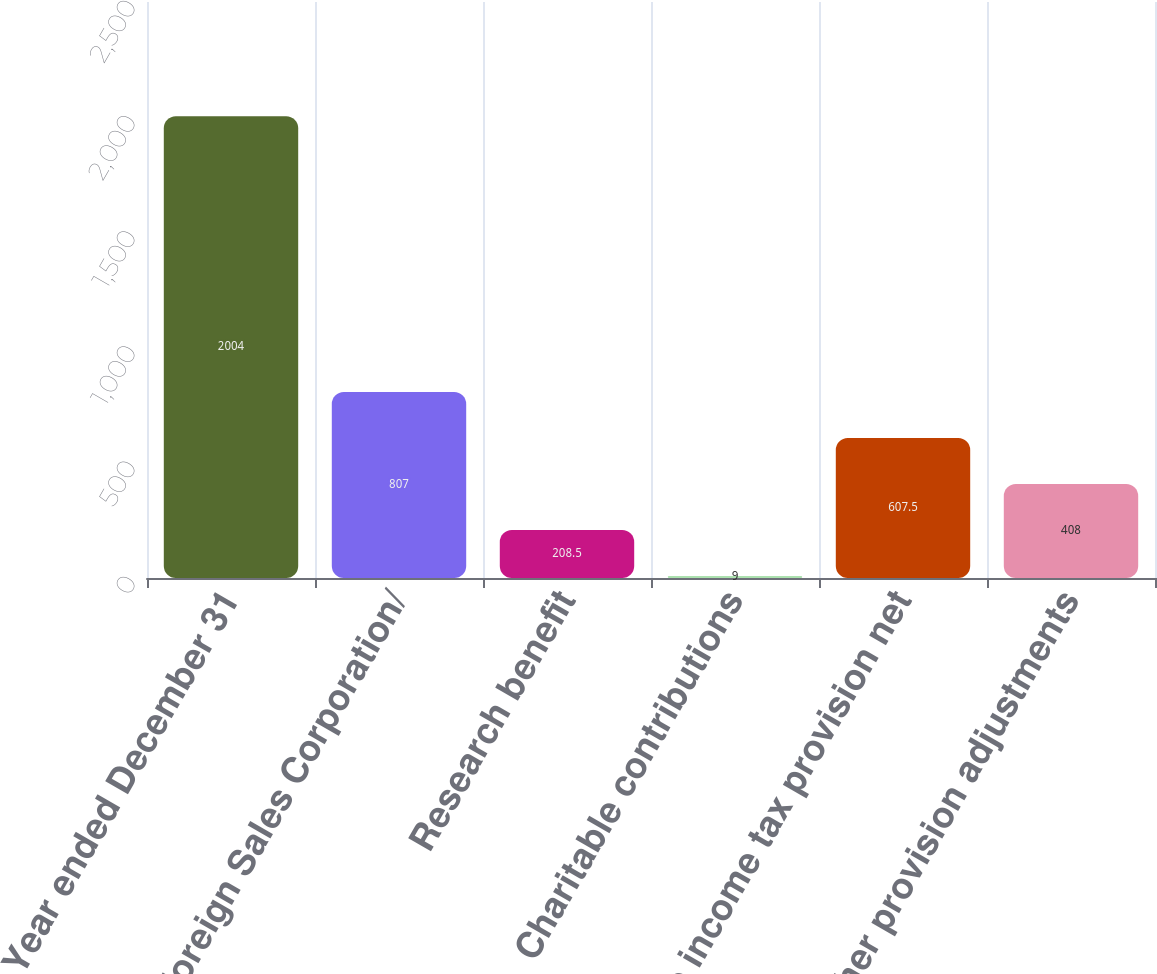Convert chart to OTSL. <chart><loc_0><loc_0><loc_500><loc_500><bar_chart><fcel>Year ended December 31<fcel>Foreign Sales Corporation/<fcel>Research benefit<fcel>Charitable contributions<fcel>State income tax provision net<fcel>Other provision adjustments<nl><fcel>2004<fcel>807<fcel>208.5<fcel>9<fcel>607.5<fcel>408<nl></chart> 